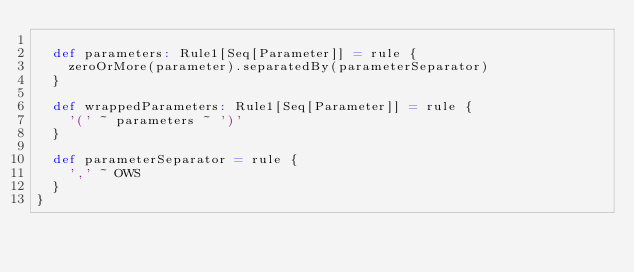Convert code to text. <code><loc_0><loc_0><loc_500><loc_500><_Scala_>
  def parameters: Rule1[Seq[Parameter]] = rule {
    zeroOrMore(parameter).separatedBy(parameterSeparator)
  }

  def wrappedParameters: Rule1[Seq[Parameter]] = rule {
    '(' ~ parameters ~ ')'
  }

  def parameterSeparator = rule {
    ',' ~ OWS
  }
}
</code> 